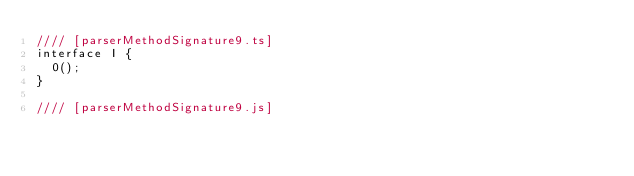Convert code to text. <code><loc_0><loc_0><loc_500><loc_500><_JavaScript_>//// [parserMethodSignature9.ts]
interface I {
  0();
}

//// [parserMethodSignature9.js]
</code> 